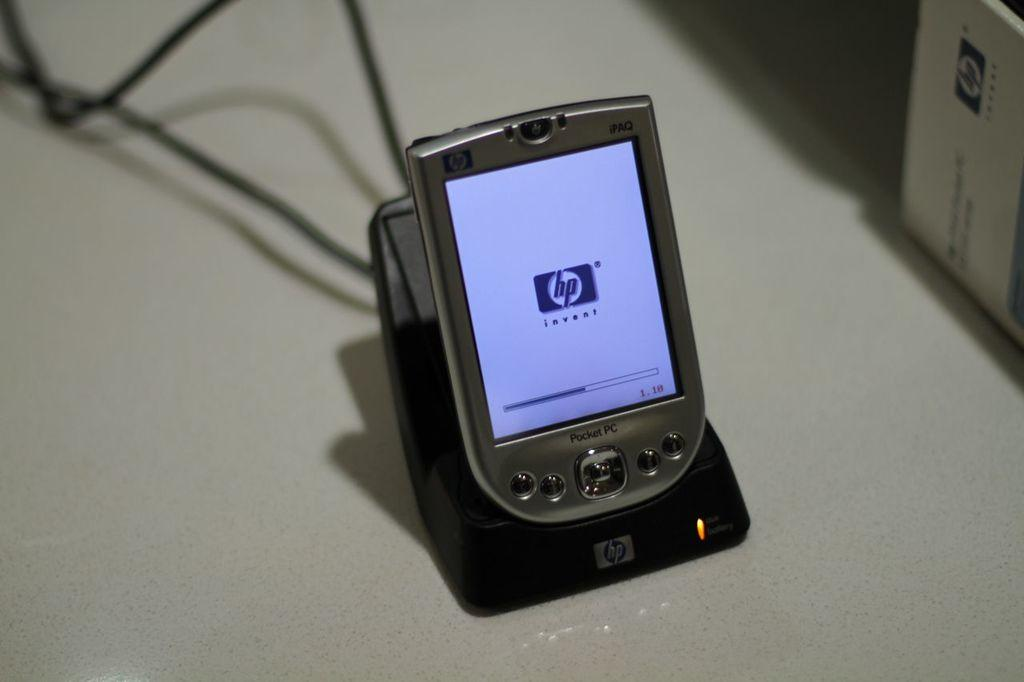<image>
Share a concise interpretation of the image provided. a small pocket pc using hp invent plugged into a charger 